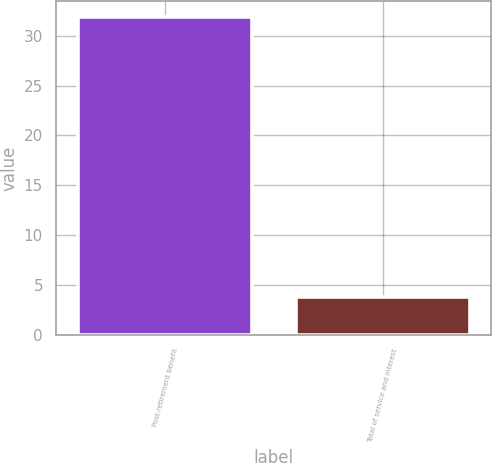Convert chart to OTSL. <chart><loc_0><loc_0><loc_500><loc_500><bar_chart><fcel>Post-retirement benefit<fcel>Total of service and interest<nl><fcel>31.9<fcel>3.8<nl></chart> 